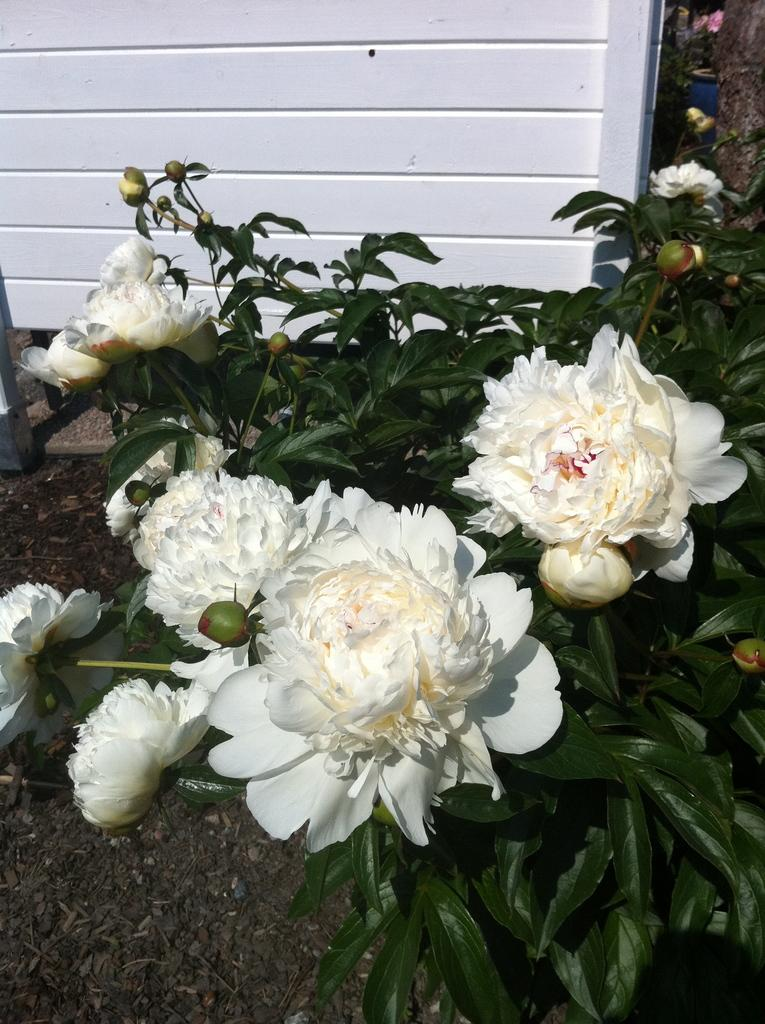What is present in the image? There is a plant in the image. What is the current state of the plant? The plant has buds and flowers in white color. What can be seen in the background of the image? There is a shed in the background of the image. What type of doctor is examining the plant in the image? There is no doctor present in the image; it features a plant with buds and white flowers, along with a shed in the background. 